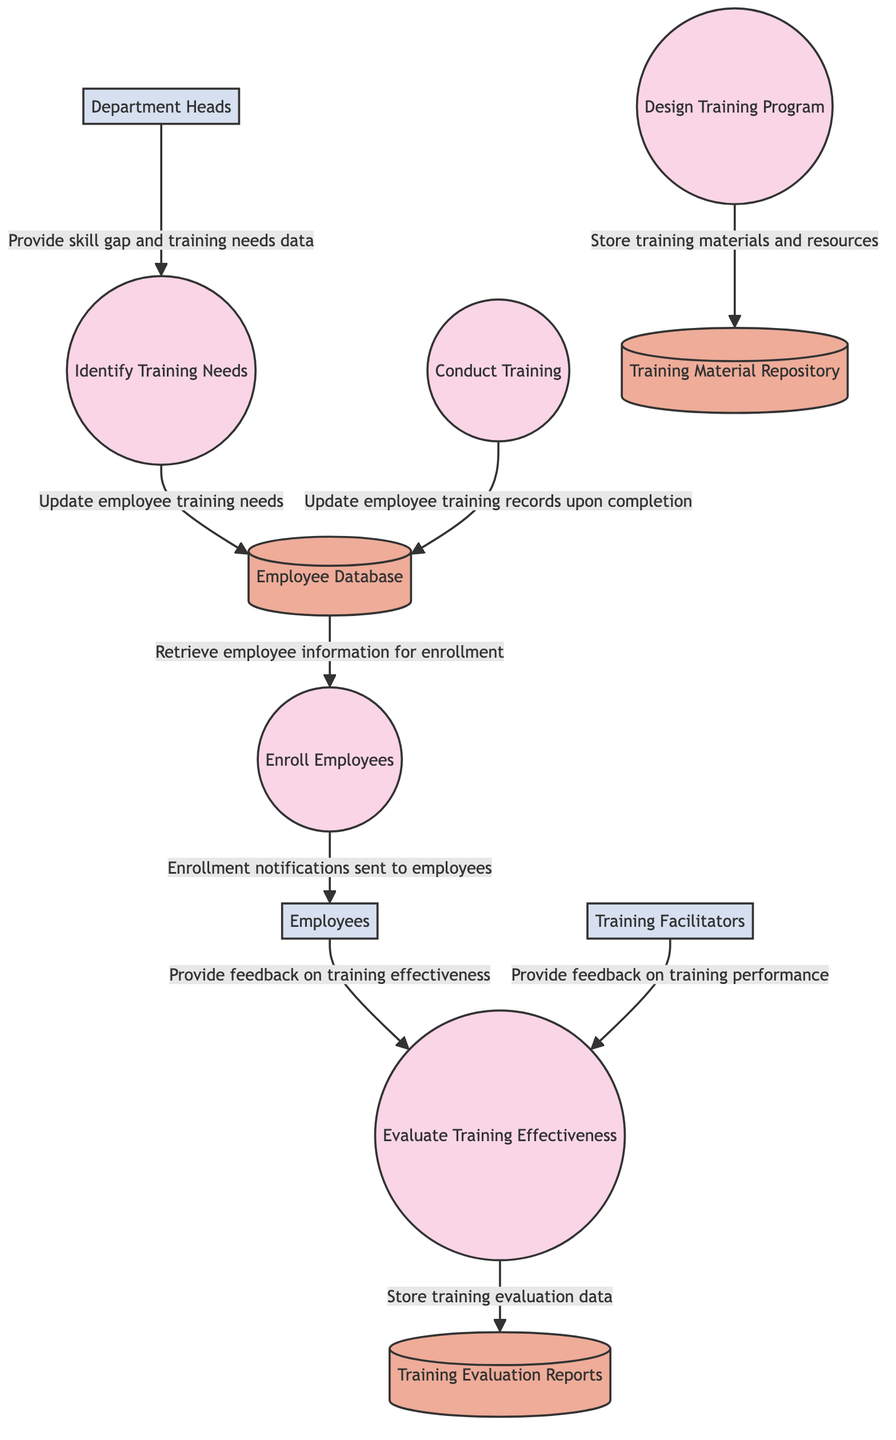What are the names of the external entities in the diagram? The diagram includes three external entities: "Department Heads," "Training Facilitators," and "Employees." These entities are identified as sources of data that interact with the processes in the training program workflow.
Answer: Department Heads, Training Facilitators, Employees Which process is responsible for evaluating the training effectiveness? The process labeled "Evaluate Training Effectiveness" is designated with the identifier P5, indicating its role in assessing the impact of the training provided.
Answer: Evaluate Training Effectiveness How many processes are present in the diagram? The diagram features five distinct processes: "Identify Training Needs," "Design Training Program," "Enroll Employees," "Conduct Training," and "Evaluate Training Effectiveness." This count is derived from their representation in the workflow.
Answer: Five What data store holds the information about employee training records? The "Employee Database" is the data store that contains detailed employee information, including their training records. This is evident from its description in the diagram.
Answer: Employee Database Which external entity provides feedback on training effectiveness? The external entity "Employees" is responsible for providing feedback on the training effectiveness, as indicated in the data flow connecting them to the evaluation process.
Answer: Employees What is the flow of data from the "Enroll Employees" process to the "Employees" entity? The "Enroll Employees" process sends enrollment notifications directly to the "Employees" entity, illustrating the communication of the enrollment outcome to employees.
Answer: Enrollment notifications sent to employees What does the "Design Training Program" process output to the data store? The "Design Training Program" process outputs training materials and resources to the "Training Material Repository," which serves as a storage location for the designed curriculum.
Answer: Store training materials and resources What type of feedback do the "Training Facilitators" provide? The "Training Facilitators" provide feedback on training performance, which contributes to the overall evaluation process regarding the effectiveness of the conducted training.
Answer: Feedback on training performance How is employee training needs information updated? Employee training needs information is updated as a result of the "Identify Training Needs" process, which takes data from the "Department Heads" entity to assess skill gaps.
Answer: Update employee training needs 